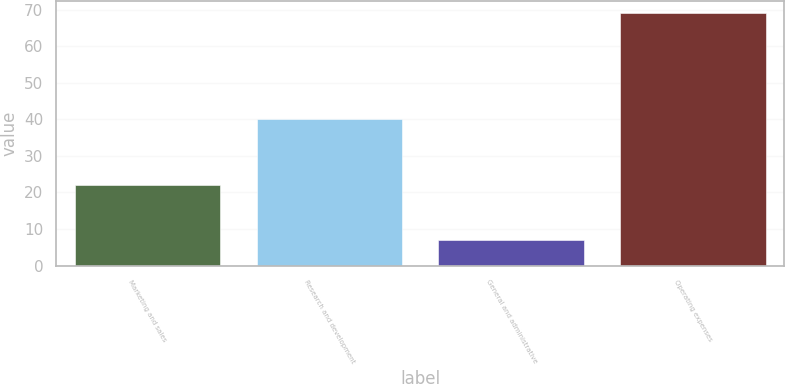Convert chart to OTSL. <chart><loc_0><loc_0><loc_500><loc_500><bar_chart><fcel>Marketing and sales<fcel>Research and development<fcel>General and administrative<fcel>Operating expenses<nl><fcel>22<fcel>40<fcel>7<fcel>69<nl></chart> 